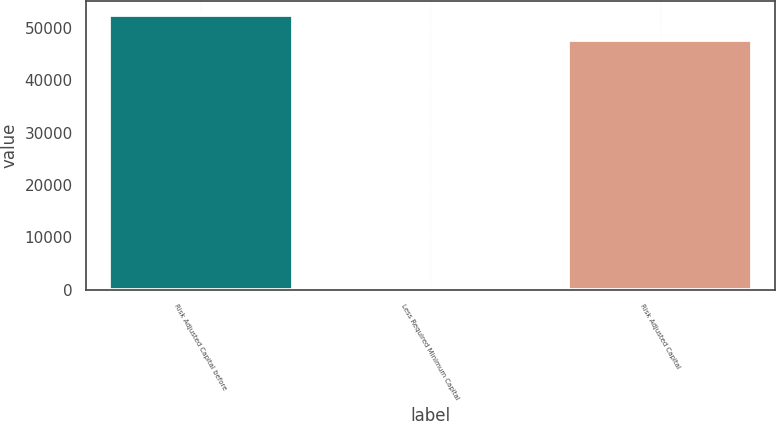Convert chart to OTSL. <chart><loc_0><loc_0><loc_500><loc_500><bar_chart><fcel>Risk Adjusted Capital before<fcel>Less Required Minimum Capital<fcel>Risk Adjusted Capital<nl><fcel>52561.3<fcel>250<fcel>47783<nl></chart> 